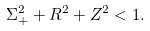Convert formula to latex. <formula><loc_0><loc_0><loc_500><loc_500>\Sigma _ { + } ^ { 2 } + R ^ { 2 } + Z ^ { 2 } < 1 .</formula> 